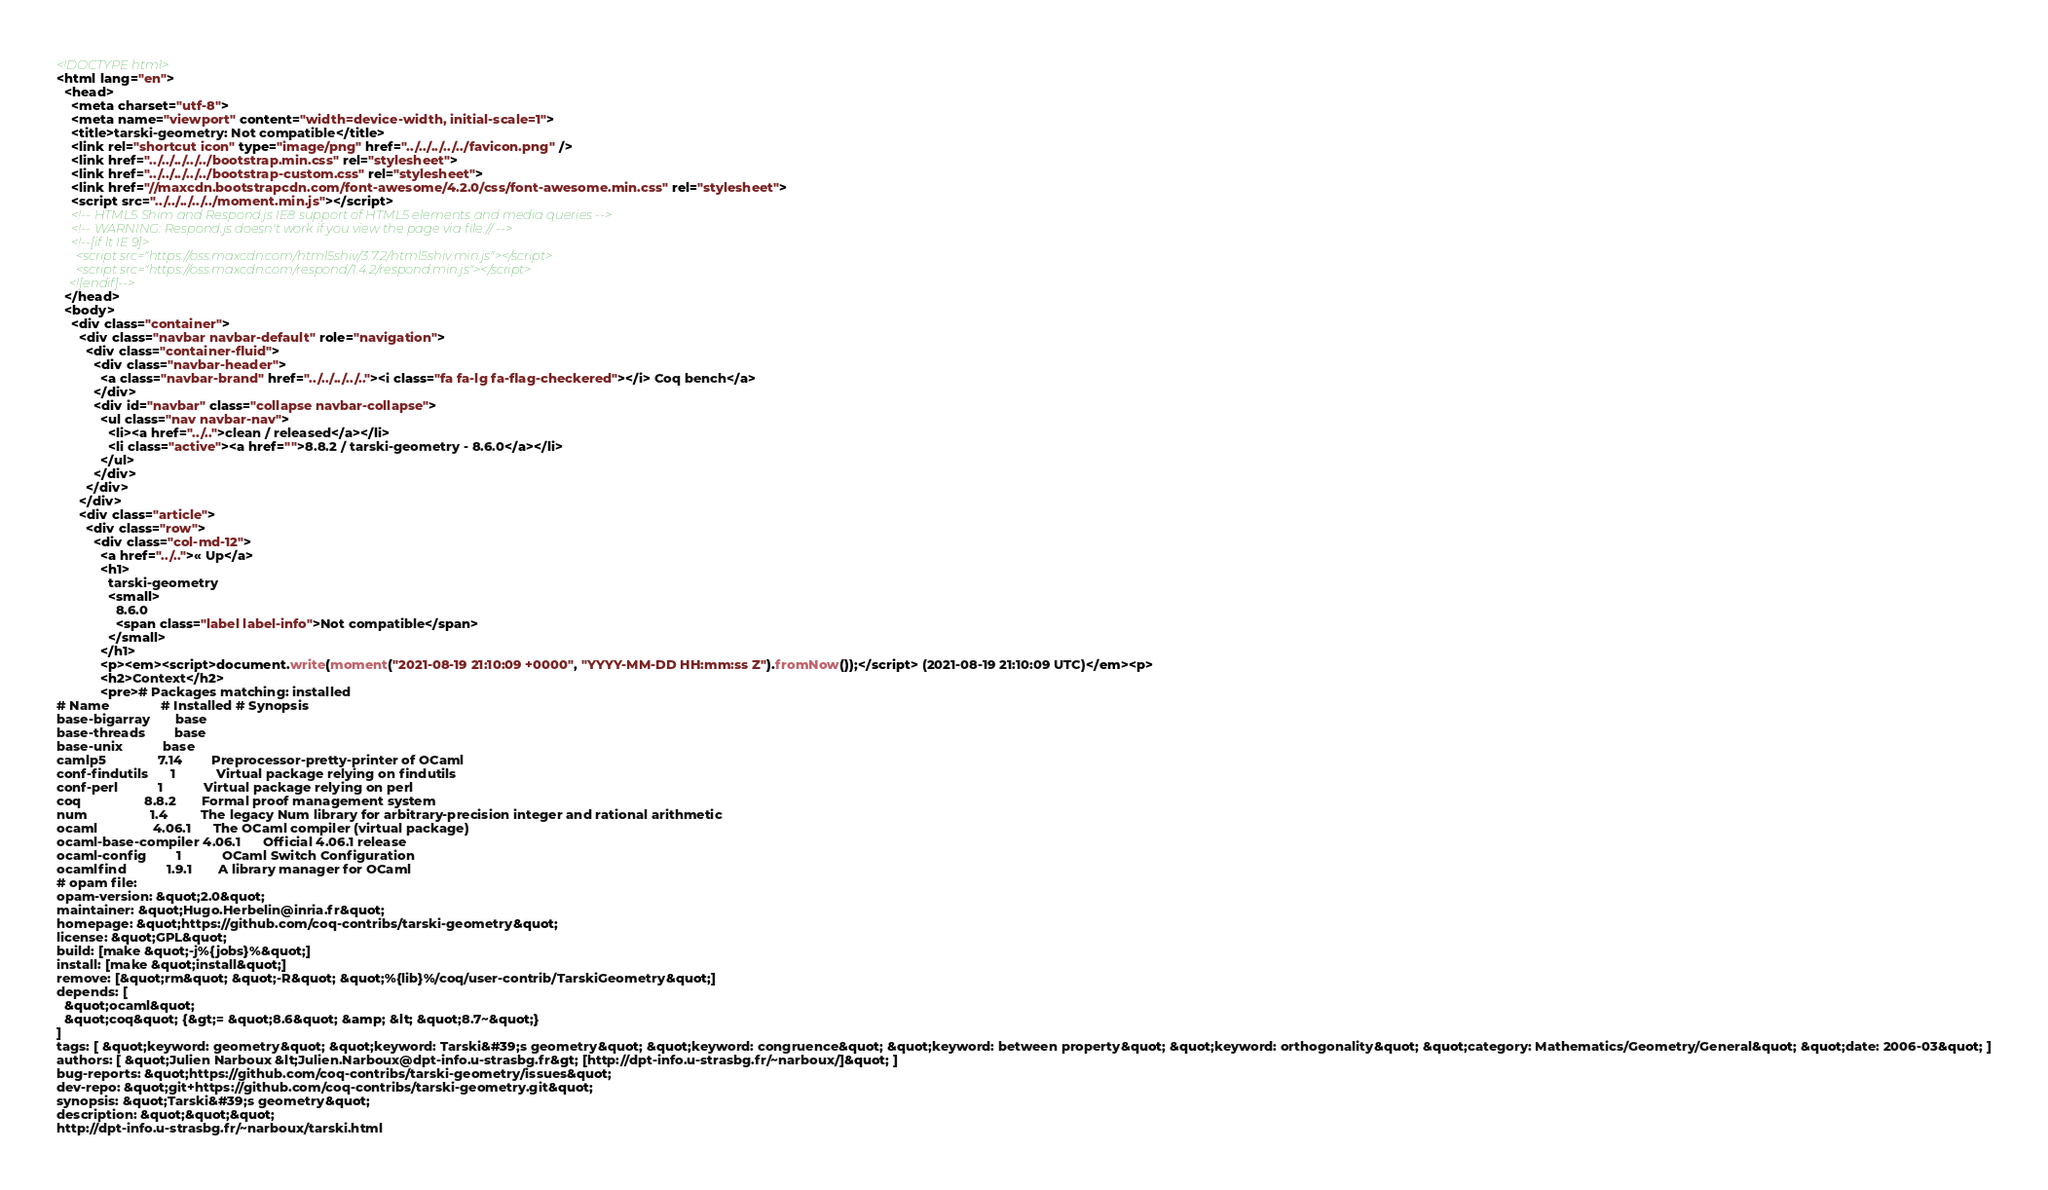Convert code to text. <code><loc_0><loc_0><loc_500><loc_500><_HTML_><!DOCTYPE html>
<html lang="en">
  <head>
    <meta charset="utf-8">
    <meta name="viewport" content="width=device-width, initial-scale=1">
    <title>tarski-geometry: Not compatible</title>
    <link rel="shortcut icon" type="image/png" href="../../../../../favicon.png" />
    <link href="../../../../../bootstrap.min.css" rel="stylesheet">
    <link href="../../../../../bootstrap-custom.css" rel="stylesheet">
    <link href="//maxcdn.bootstrapcdn.com/font-awesome/4.2.0/css/font-awesome.min.css" rel="stylesheet">
    <script src="../../../../../moment.min.js"></script>
    <!-- HTML5 Shim and Respond.js IE8 support of HTML5 elements and media queries -->
    <!-- WARNING: Respond.js doesn't work if you view the page via file:// -->
    <!--[if lt IE 9]>
      <script src="https://oss.maxcdn.com/html5shiv/3.7.2/html5shiv.min.js"></script>
      <script src="https://oss.maxcdn.com/respond/1.4.2/respond.min.js"></script>
    <![endif]-->
  </head>
  <body>
    <div class="container">
      <div class="navbar navbar-default" role="navigation">
        <div class="container-fluid">
          <div class="navbar-header">
            <a class="navbar-brand" href="../../../../.."><i class="fa fa-lg fa-flag-checkered"></i> Coq bench</a>
          </div>
          <div id="navbar" class="collapse navbar-collapse">
            <ul class="nav navbar-nav">
              <li><a href="../..">clean / released</a></li>
              <li class="active"><a href="">8.8.2 / tarski-geometry - 8.6.0</a></li>
            </ul>
          </div>
        </div>
      </div>
      <div class="article">
        <div class="row">
          <div class="col-md-12">
            <a href="../..">« Up</a>
            <h1>
              tarski-geometry
              <small>
                8.6.0
                <span class="label label-info">Not compatible</span>
              </small>
            </h1>
            <p><em><script>document.write(moment("2021-08-19 21:10:09 +0000", "YYYY-MM-DD HH:mm:ss Z").fromNow());</script> (2021-08-19 21:10:09 UTC)</em><p>
            <h2>Context</h2>
            <pre># Packages matching: installed
# Name              # Installed # Synopsis
base-bigarray       base
base-threads        base
base-unix           base
camlp5              7.14        Preprocessor-pretty-printer of OCaml
conf-findutils      1           Virtual package relying on findutils
conf-perl           1           Virtual package relying on perl
coq                 8.8.2       Formal proof management system
num                 1.4         The legacy Num library for arbitrary-precision integer and rational arithmetic
ocaml               4.06.1      The OCaml compiler (virtual package)
ocaml-base-compiler 4.06.1      Official 4.06.1 release
ocaml-config        1           OCaml Switch Configuration
ocamlfind           1.9.1       A library manager for OCaml
# opam file:
opam-version: &quot;2.0&quot;
maintainer: &quot;Hugo.Herbelin@inria.fr&quot;
homepage: &quot;https://github.com/coq-contribs/tarski-geometry&quot;
license: &quot;GPL&quot;
build: [make &quot;-j%{jobs}%&quot;]
install: [make &quot;install&quot;]
remove: [&quot;rm&quot; &quot;-R&quot; &quot;%{lib}%/coq/user-contrib/TarskiGeometry&quot;]
depends: [
  &quot;ocaml&quot;
  &quot;coq&quot; {&gt;= &quot;8.6&quot; &amp; &lt; &quot;8.7~&quot;}
]
tags: [ &quot;keyword: geometry&quot; &quot;keyword: Tarski&#39;s geometry&quot; &quot;keyword: congruence&quot; &quot;keyword: between property&quot; &quot;keyword: orthogonality&quot; &quot;category: Mathematics/Geometry/General&quot; &quot;date: 2006-03&quot; ]
authors: [ &quot;Julien Narboux &lt;Julien.Narboux@dpt-info.u-strasbg.fr&gt; [http://dpt-info.u-strasbg.fr/~narboux/]&quot; ]
bug-reports: &quot;https://github.com/coq-contribs/tarski-geometry/issues&quot;
dev-repo: &quot;git+https://github.com/coq-contribs/tarski-geometry.git&quot;
synopsis: &quot;Tarski&#39;s geometry&quot;
description: &quot;&quot;&quot;
http://dpt-info.u-strasbg.fr/~narboux/tarski.html</code> 